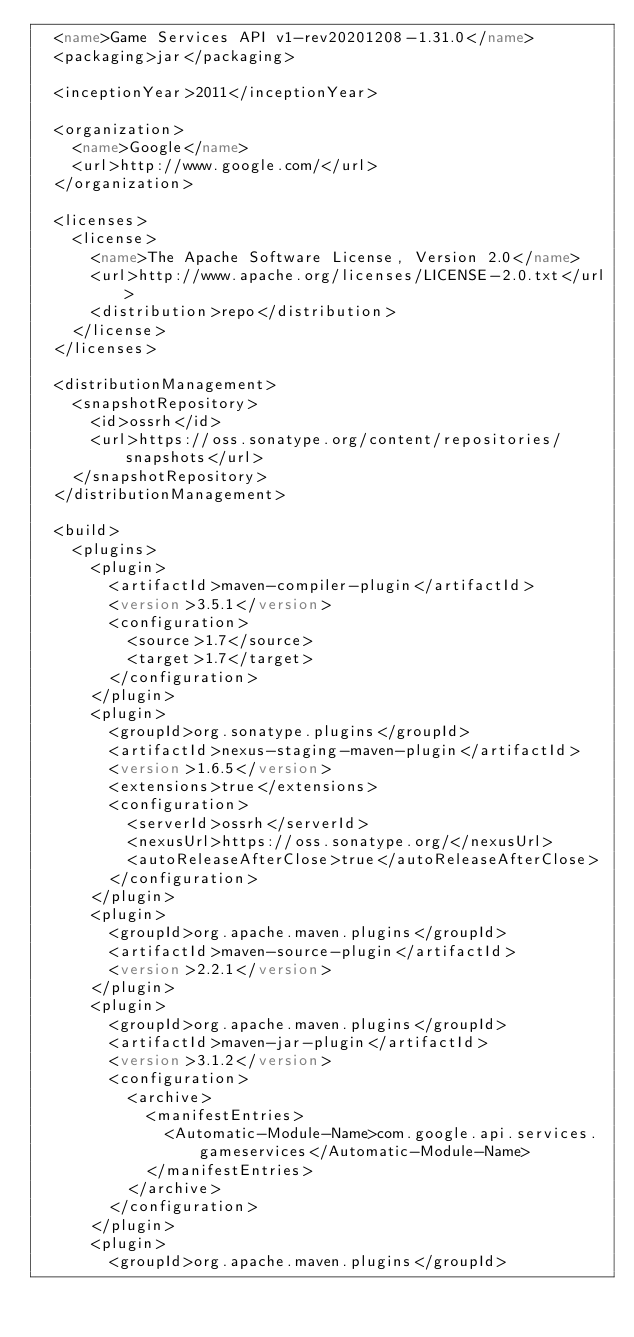Convert code to text. <code><loc_0><loc_0><loc_500><loc_500><_XML_>  <name>Game Services API v1-rev20201208-1.31.0</name>
  <packaging>jar</packaging>

  <inceptionYear>2011</inceptionYear>

  <organization>
    <name>Google</name>
    <url>http://www.google.com/</url>
  </organization>

  <licenses>
    <license>
      <name>The Apache Software License, Version 2.0</name>
      <url>http://www.apache.org/licenses/LICENSE-2.0.txt</url>
      <distribution>repo</distribution>
    </license>
  </licenses>

  <distributionManagement>
    <snapshotRepository>
      <id>ossrh</id>
      <url>https://oss.sonatype.org/content/repositories/snapshots</url>
    </snapshotRepository>
  </distributionManagement>

  <build>
    <plugins>
      <plugin>
        <artifactId>maven-compiler-plugin</artifactId>
        <version>3.5.1</version>
        <configuration>
          <source>1.7</source>
          <target>1.7</target>
        </configuration>
      </plugin>
      <plugin>
        <groupId>org.sonatype.plugins</groupId>
        <artifactId>nexus-staging-maven-plugin</artifactId>
        <version>1.6.5</version>
        <extensions>true</extensions>
        <configuration>
          <serverId>ossrh</serverId>
          <nexusUrl>https://oss.sonatype.org/</nexusUrl>
          <autoReleaseAfterClose>true</autoReleaseAfterClose>
        </configuration>
      </plugin>
      <plugin>
        <groupId>org.apache.maven.plugins</groupId>
        <artifactId>maven-source-plugin</artifactId>
        <version>2.2.1</version>
      </plugin>
      <plugin>
        <groupId>org.apache.maven.plugins</groupId>
        <artifactId>maven-jar-plugin</artifactId>
        <version>3.1.2</version>
        <configuration>
          <archive>
            <manifestEntries>
              <Automatic-Module-Name>com.google.api.services.gameservices</Automatic-Module-Name>
            </manifestEntries>
          </archive>
        </configuration>
      </plugin>
      <plugin>
        <groupId>org.apache.maven.plugins</groupId></code> 